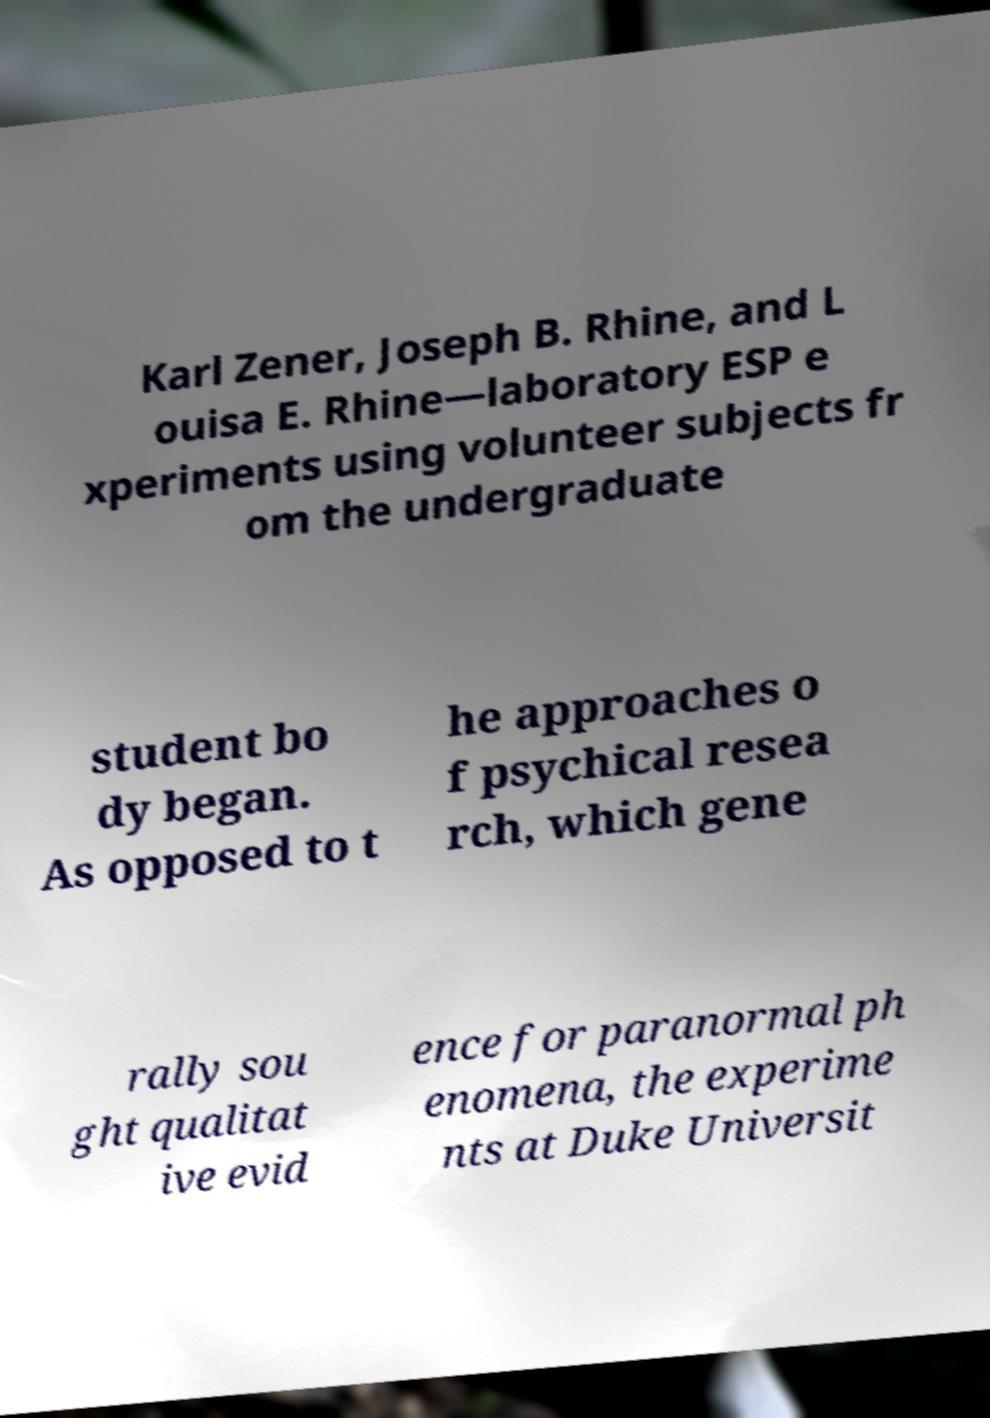Can you accurately transcribe the text from the provided image for me? Karl Zener, Joseph B. Rhine, and L ouisa E. Rhine—laboratory ESP e xperiments using volunteer subjects fr om the undergraduate student bo dy began. As opposed to t he approaches o f psychical resea rch, which gene rally sou ght qualitat ive evid ence for paranormal ph enomena, the experime nts at Duke Universit 